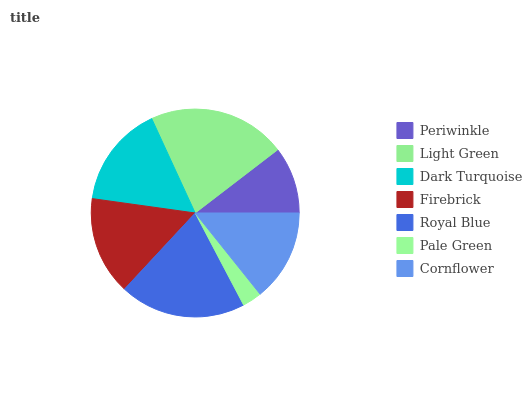Is Pale Green the minimum?
Answer yes or no. Yes. Is Light Green the maximum?
Answer yes or no. Yes. Is Dark Turquoise the minimum?
Answer yes or no. No. Is Dark Turquoise the maximum?
Answer yes or no. No. Is Light Green greater than Dark Turquoise?
Answer yes or no. Yes. Is Dark Turquoise less than Light Green?
Answer yes or no. Yes. Is Dark Turquoise greater than Light Green?
Answer yes or no. No. Is Light Green less than Dark Turquoise?
Answer yes or no. No. Is Firebrick the high median?
Answer yes or no. Yes. Is Firebrick the low median?
Answer yes or no. Yes. Is Light Green the high median?
Answer yes or no. No. Is Royal Blue the low median?
Answer yes or no. No. 